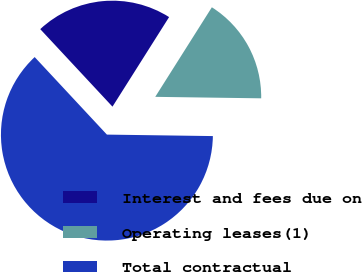<chart> <loc_0><loc_0><loc_500><loc_500><pie_chart><fcel>Interest and fees due on<fcel>Operating leases(1)<fcel>Total contractual<nl><fcel>20.91%<fcel>16.25%<fcel>62.84%<nl></chart> 